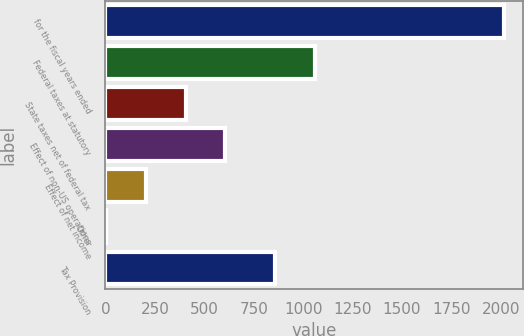Convert chart to OTSL. <chart><loc_0><loc_0><loc_500><loc_500><bar_chart><fcel>for the fiscal years ended<fcel>Federal taxes at statutory<fcel>State taxes net of federal tax<fcel>Effect of non-US operations<fcel>Effect of net income<fcel>Other<fcel>Tax Provision<nl><fcel>2013<fcel>1059.3<fcel>406.12<fcel>606.98<fcel>205.26<fcel>4.4<fcel>855.9<nl></chart> 